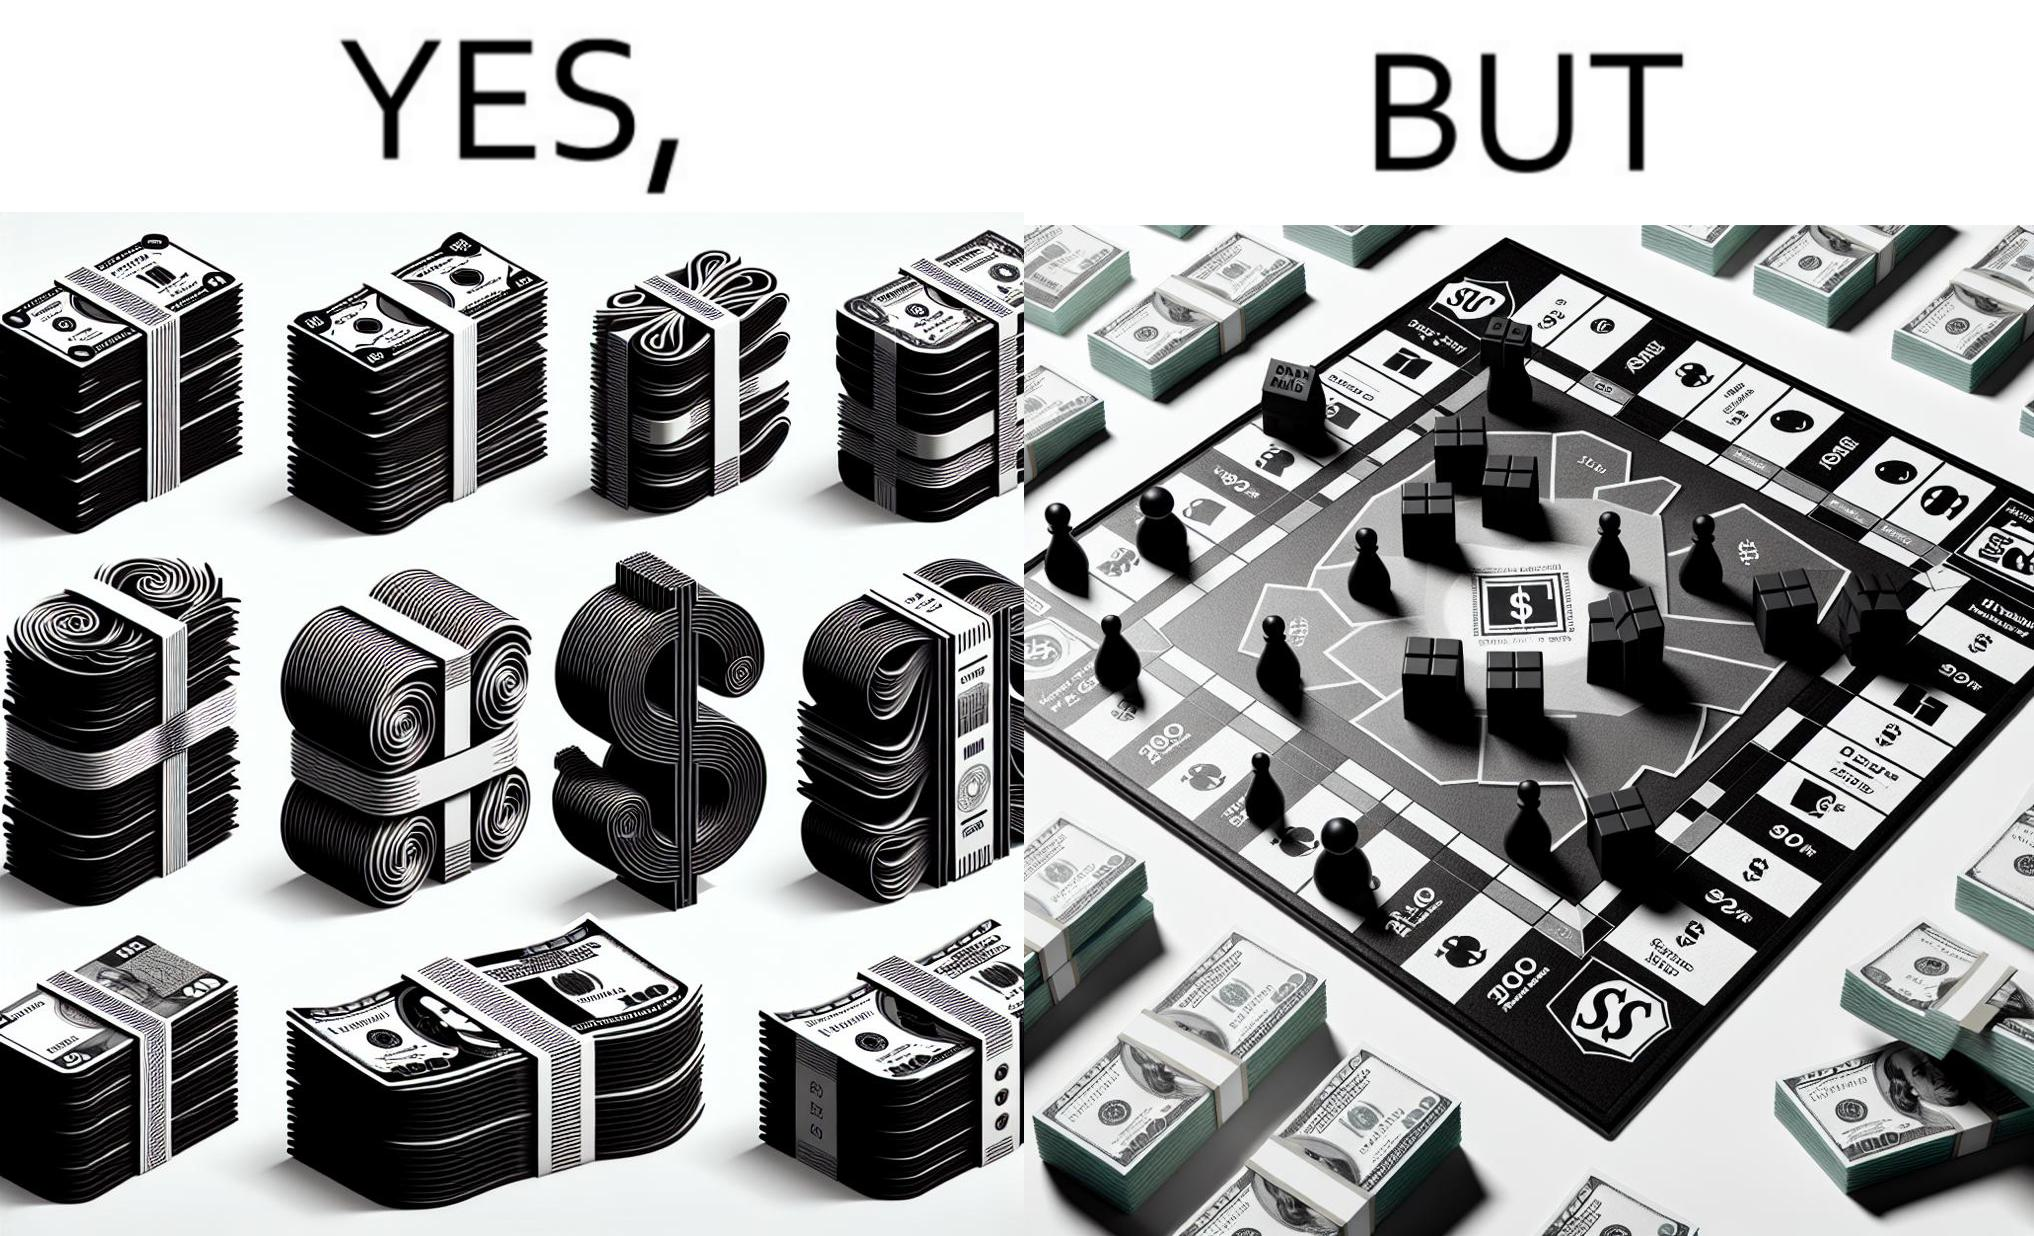What does this image depict? The image is ironic, because there are many different color currency notes' bundles but they are just as a currency in the game of monopoly and they have no real value 